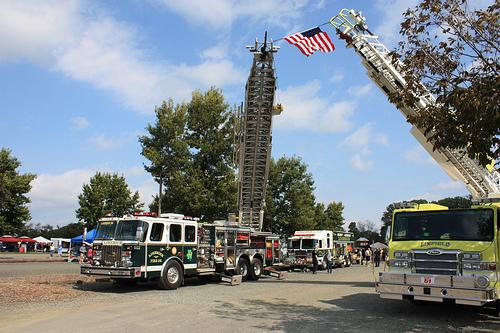Mention the two main vehicles in the image and the main accessory they are holding. The image features a white and green fire truck and a yellow fire truck, both with ladders raised and suspending a red, white and blue American flag. Mention the main objects on display along with their colors and positions. There are two fire trucks, one white and green and the other yellow, with ladders raised suspending an American red, white, and blue flag in the air. Discuss the primary theme and setting of the image. The image shows a patriotic event with two fire trucks suspending an American flag, surrounded by people and tall trees, under a partly cloudy sky. Discuss the focal point of the photograph along with the condition of the sky. The main focus is two fire trucks suspending an American flag, and the sky is partly cloudy with white clouds against a clear blue backdrop. Provide a concise description of the image, primarily focusing on the flag and its location. An American flag is suspended in the air between two fire trucks with raised ladders, under a partly cloudy sky. Explain the visual elements in the image, primarily focusing on the fire trucks and the flag. Two fire trucks, one white and green and the other yellow, are parked side by side with raised ladders holding an American flag, under a partly cloudy sky. Describe the scene captured in the image mainly focusing on the vehicles. The image shows two parked fire trucks - one green and white, and the other bright yellow - with raised ladders holding up an American flag. Describe the environment and atmosphere of the depicted scene. The image captures a patriotic scene with firetrucks displaying the American flag, people gathered around and a partly cloudy sky in broad daylight. Give a brief overview of the items present in the picture and their arrangement. There are two fire trucks with raised ladders, an American flag flying in between, people standing on the ground, and a partly cloudy sky above. Describe how the American flag is showcased in the photograph. The American flag is held in the air, flying between two fire trucks with raised ladders, creating a captivating and patriotic scene. 